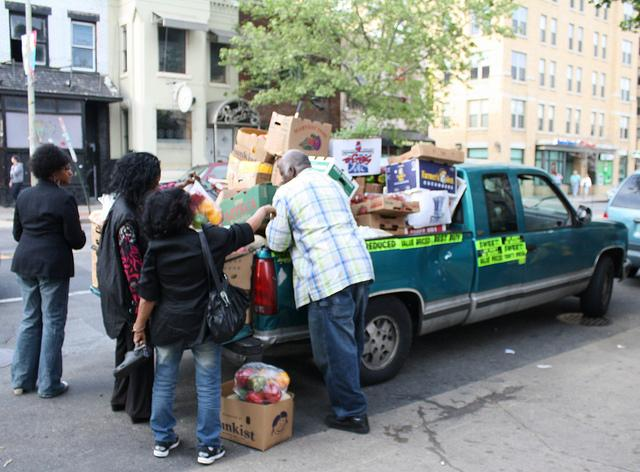Why is there green tape on the pickup? advertising 